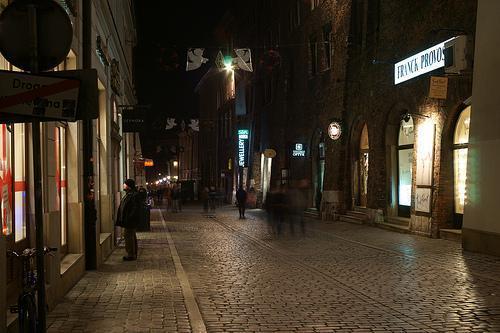How many large signs are visible?
Give a very brief answer. 1. 